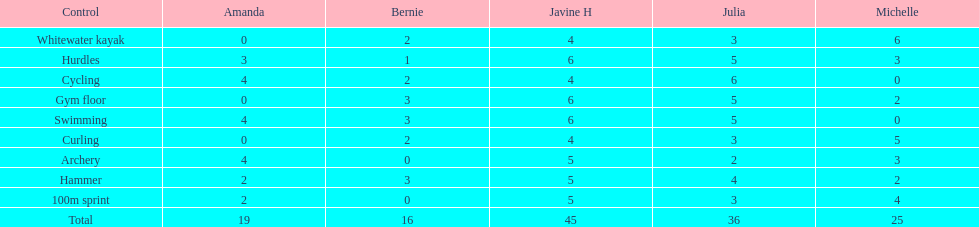Who scored the least on whitewater kayak? Amanda. 